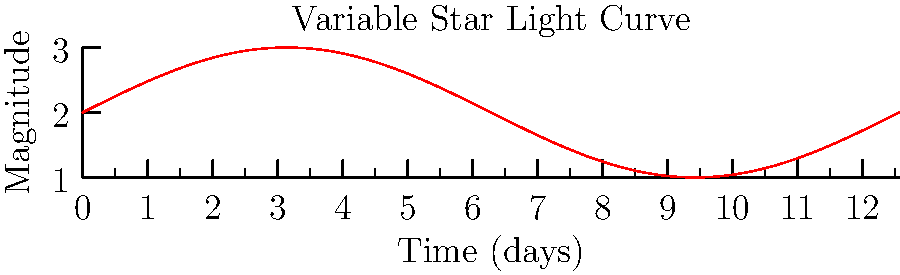Given the light curve of a variable star shown in the graph, what is the approximate period of the star's brightness variation in days? To determine the period of the variable star's brightness variation, we need to follow these steps:

1. Identify the pattern: The light curve shows a sinusoidal pattern, which is typical for many types of variable stars.

2. Locate peaks or troughs: We can see that the curve completes one full cycle between two consecutive peaks or troughs.

3. Measure the time between peaks: The x-axis represents time in days. We need to find the time difference between two consecutive peaks or troughs.

4. Analyze the graph:
   - The x-axis spans from 0 to $4\pi$ days.
   - We can see that one complete cycle occurs between 0 and $2\pi$ on the x-axis.

5. Convert to days:
   $2\pi$ radians = 360°, which corresponds to one full period.
   In this case, $2\pi$ on the x-axis represents the period in days.

6. Calculate the period:
   Period = $2\pi$ days ≈ 6.28 days

Therefore, the approximate period of the star's brightness variation is about 6.28 days.
Answer: 6.28 days 